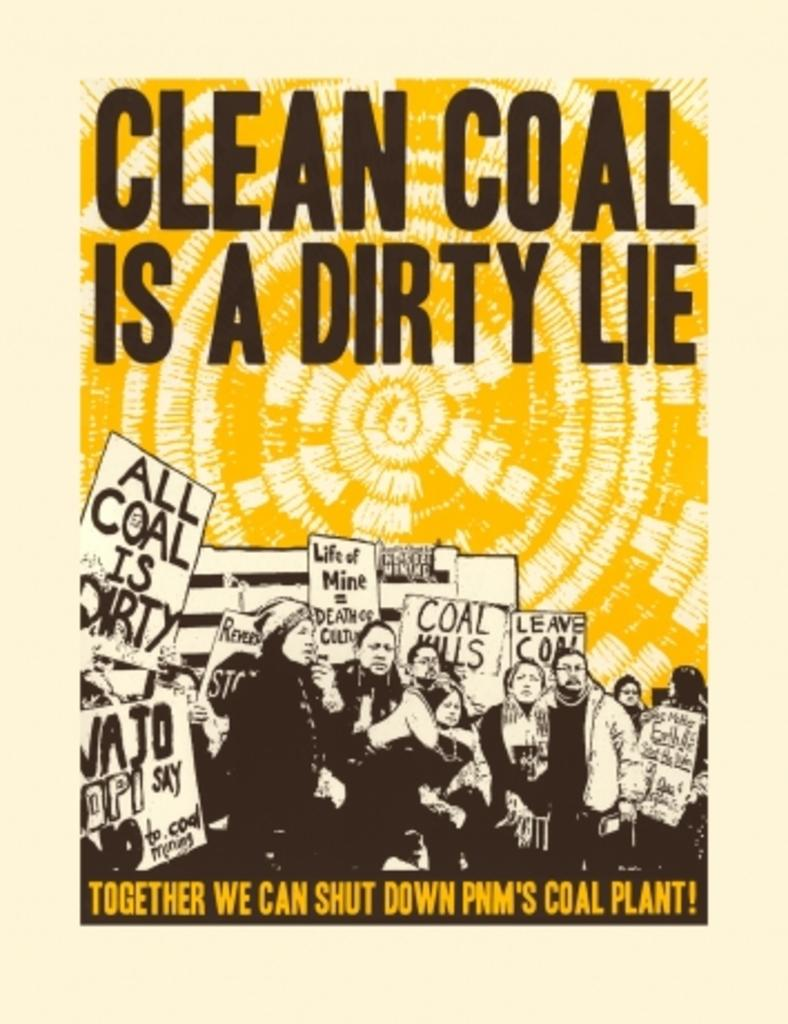Provide a one-sentence caption for the provided image. a poster with the slogan 'clean coal is a dirty lie'. 